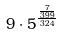Convert formula to latex. <formula><loc_0><loc_0><loc_500><loc_500>9 \cdot 5 ^ { \frac { \frac { 7 } { 3 9 9 } } { 3 2 4 } }</formula> 